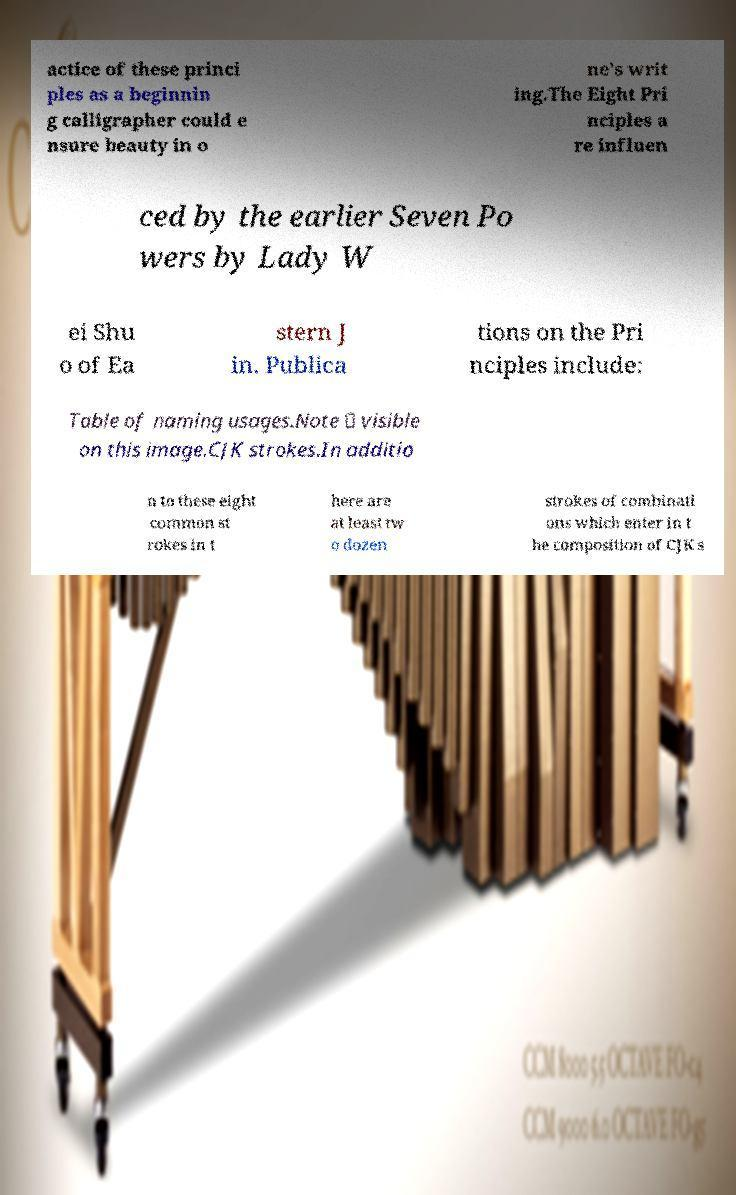There's text embedded in this image that I need extracted. Can you transcribe it verbatim? actice of these princi ples as a beginnin g calligrapher could e nsure beauty in o ne's writ ing.The Eight Pri nciples a re influen ced by the earlier Seven Po wers by Lady W ei Shu o of Ea stern J in. Publica tions on the Pri nciples include: Table of naming usages.Note － visible on this image.CJK strokes.In additio n to these eight common st rokes in t here are at least tw o dozen strokes of combinati ons which enter in t he composition of CJK s 